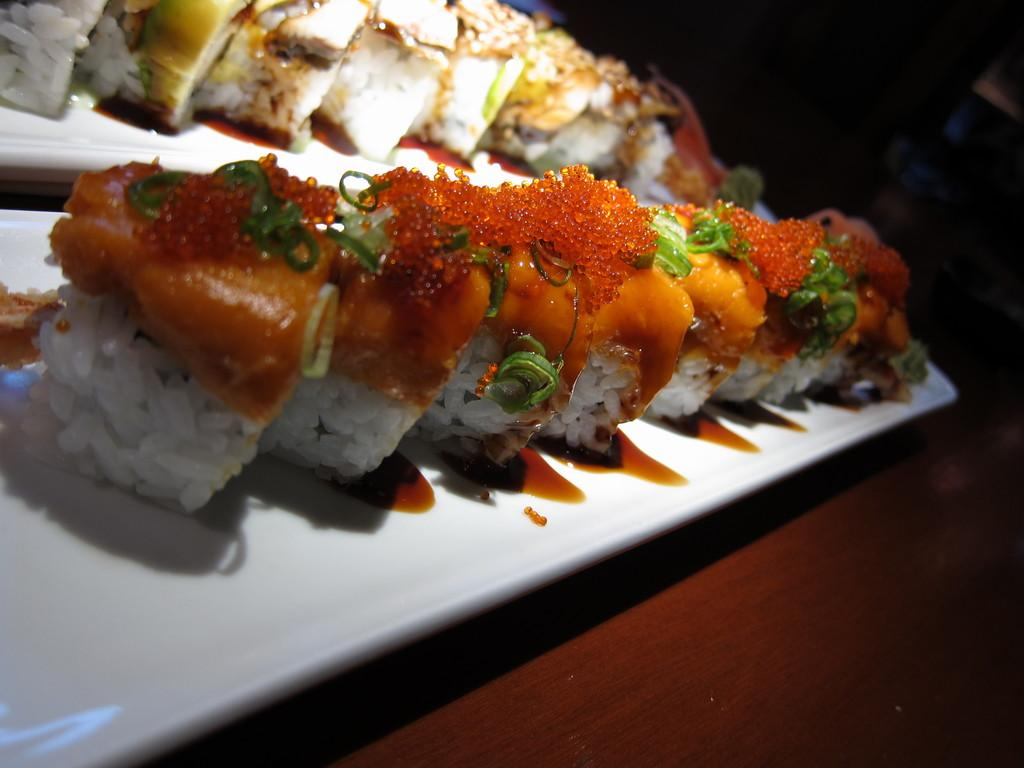What is present on the plates in the image? There are food items on plates in the image. Where are the plates with food items located? The food items are on a platform. What can be observed about the background of the image? The background of the image is dark. How many trucks are visible in the image? There are no trucks present in the image. What type of burn can be seen on the food items in the image? There is no burn visible on the food items in the image. 